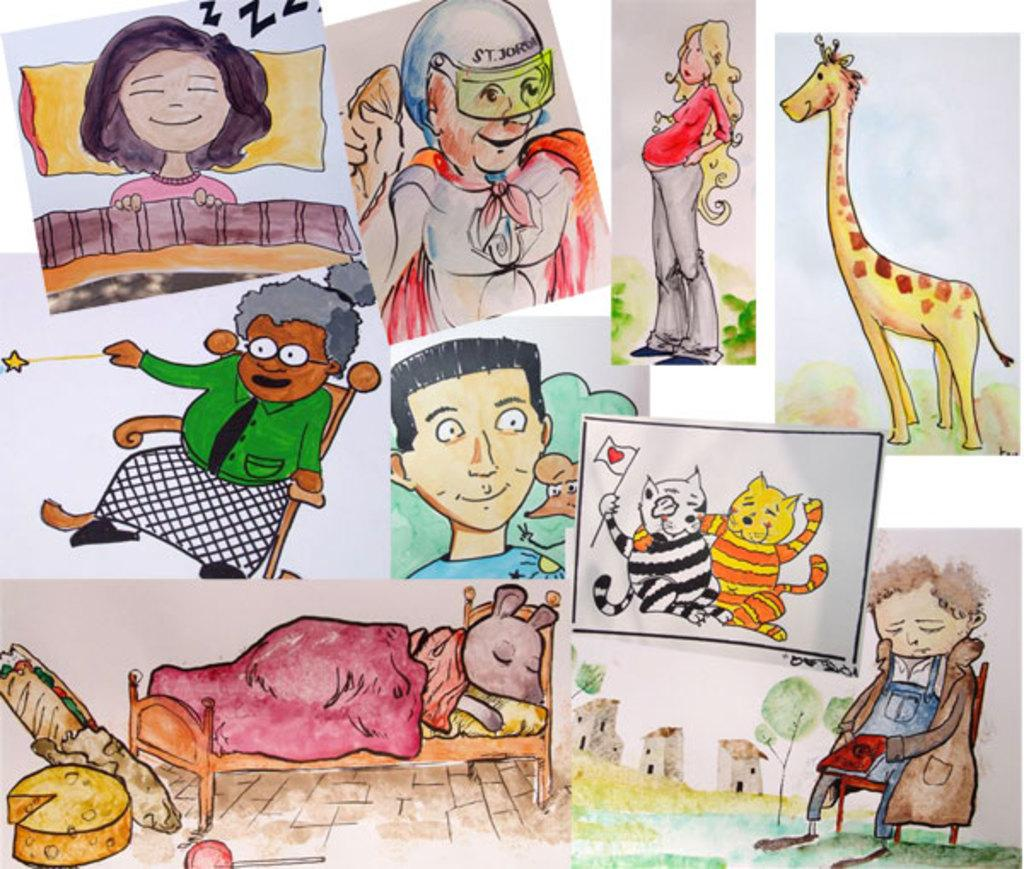What type of images are present in the image? There are cartoon images of people, animals, buildings, trees, and objects in the image. Can you describe the style of the images? The images are cartoon-style, meaning they are simplified and stylized representations of people, animals, buildings, trees, and objects. What is the common theme among the images? The common theme among the images is that they are all cartoon-style depictions of various subjects. Are there any snails attacking the cartoon buildings in the image? There are no snails or attacks present in the image; it only contains cartoon images of people, animals, buildings, trees, and objects. 